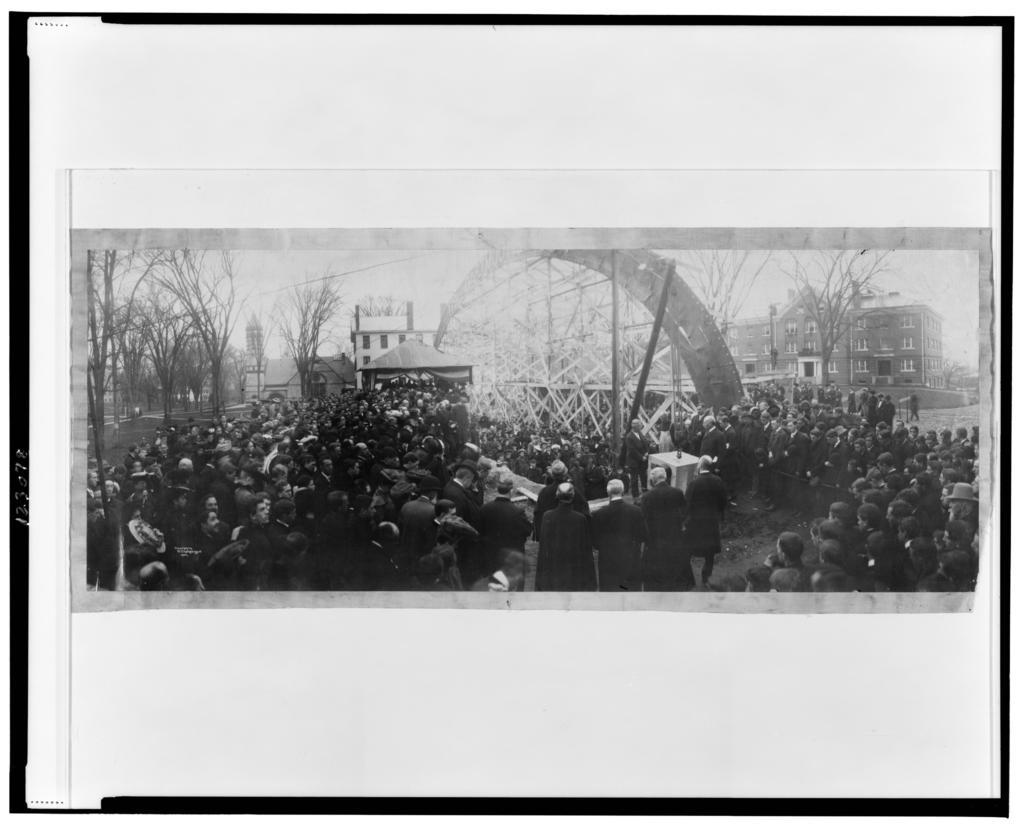What is the color scheme of the image? The image is black and white. What can be seen on the poster in the picture? There is a poster with an image in the picture. What are the people in the image doing? The people are standing on the road. What type of vegetation is visible in the image? There are trees visible in the image. What type of structures can be seen in the image? There are buildings in the image. What type of curve can be seen in the image? There is no curve present in the image. What is the hope that the people in the image are holding? There is no indication of hope being held by the people in the image. What type of thing is being depicted in the image? The image is black and white, with a poster, people standing on the road, trees, and buildings. There is no single "thing" being depicted. 